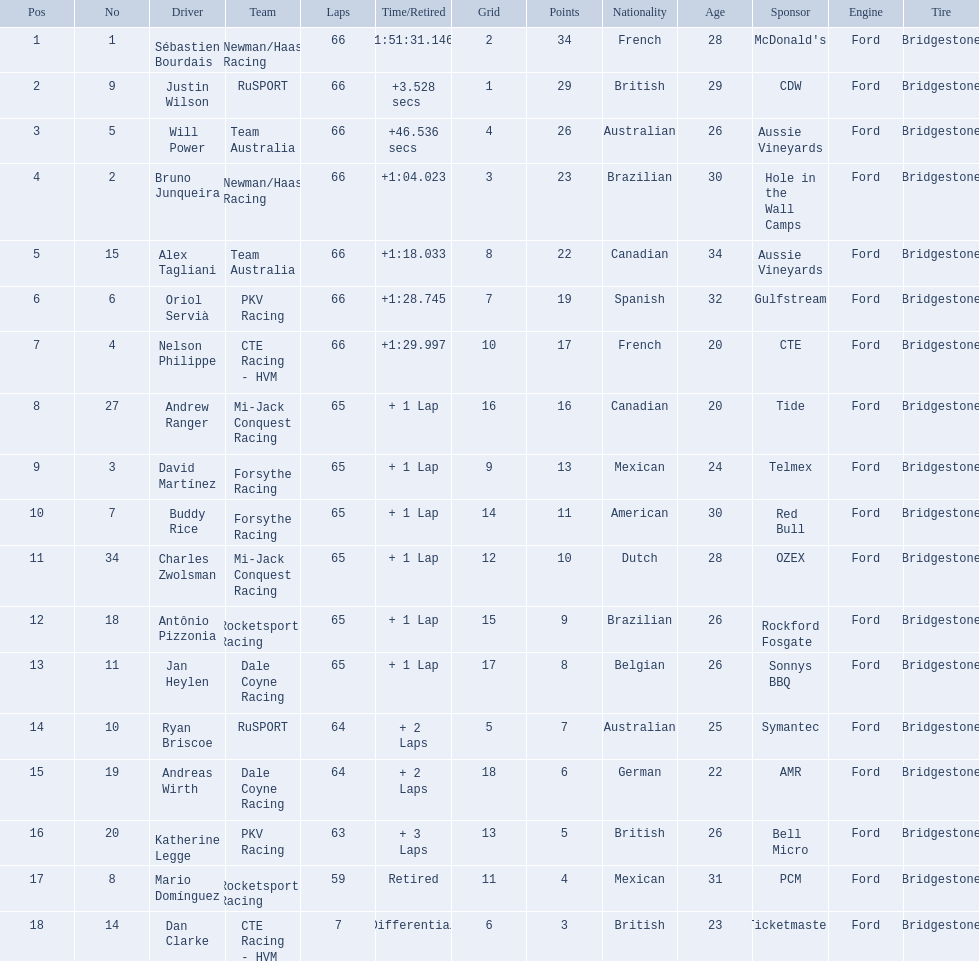Which people scored 29+ points? Sébastien Bourdais, Justin Wilson. Who scored higher? Sébastien Bourdais. 